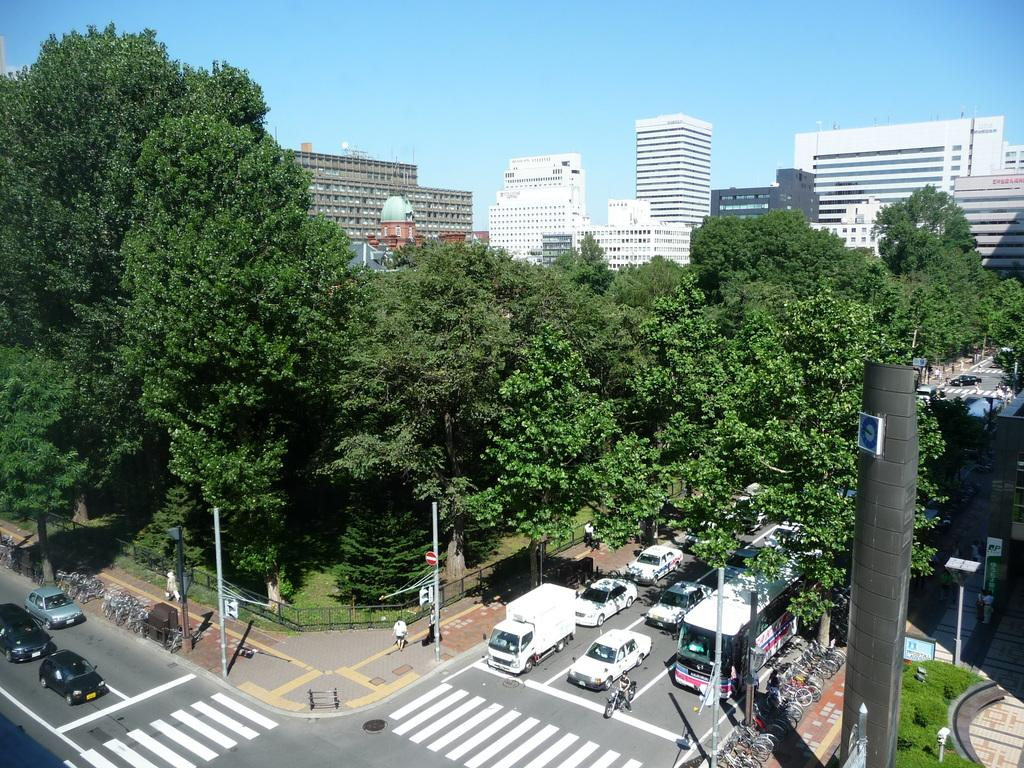What can be seen on the roadside in the image? There are vehicles on the roadside in the image. What are the people in the image doing? There are people walking in the image. What type of structures can be seen in the image? There are buildings visible in the image. What type of vegetation is present in the image? There are trees present in the image. Can you see any cactus plants in the image? There is no cactus plant present in the image. Are there any fights happening between the people in the image? There is no indication of a fight in the image; people are simply walking. 